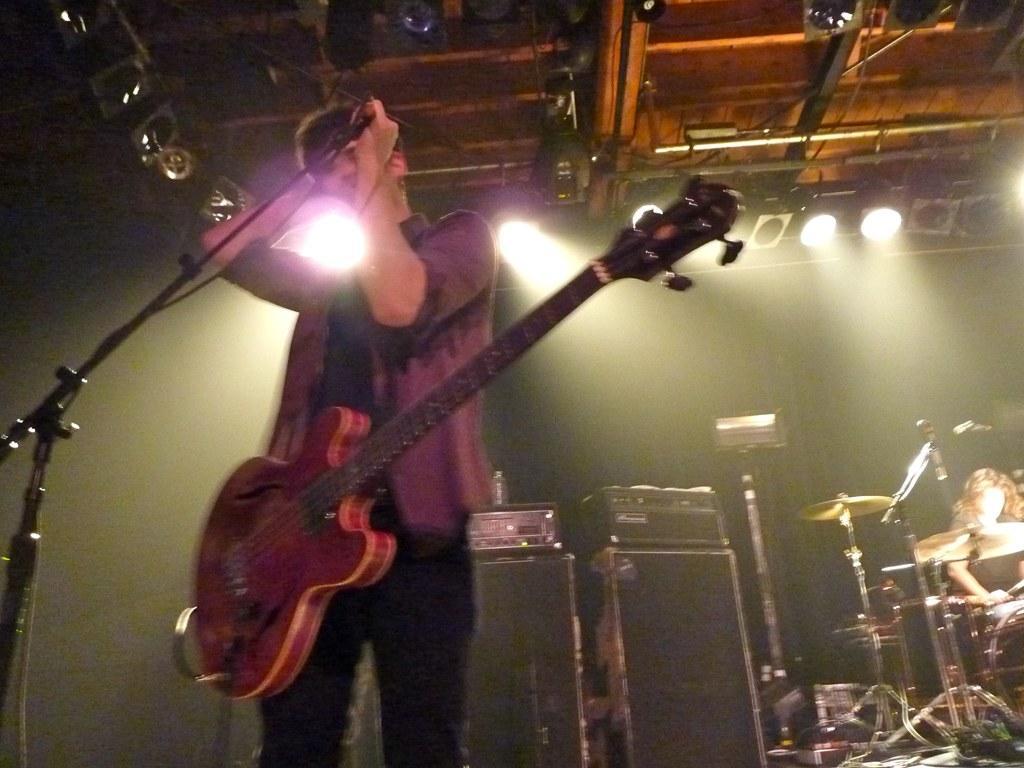In one or two sentences, can you explain what this image depicts? In this picture we can see a man with a guitar and the man is holding a microphone with a stand. Behind the man there are musical instruments and a person is sitting. Behind the people there is a dark background and at the top there are lights. 